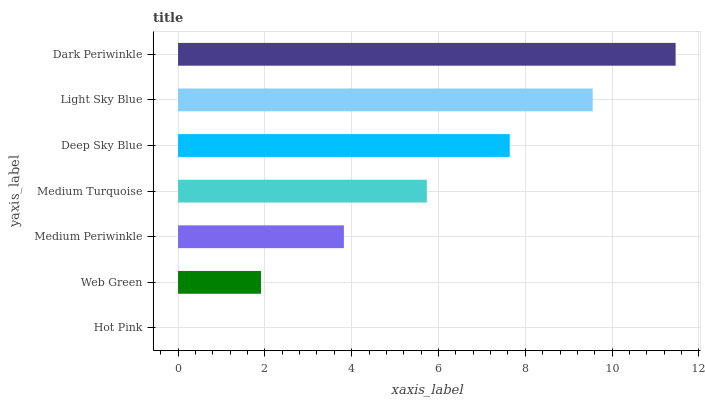Is Hot Pink the minimum?
Answer yes or no. Yes. Is Dark Periwinkle the maximum?
Answer yes or no. Yes. Is Web Green the minimum?
Answer yes or no. No. Is Web Green the maximum?
Answer yes or no. No. Is Web Green greater than Hot Pink?
Answer yes or no. Yes. Is Hot Pink less than Web Green?
Answer yes or no. Yes. Is Hot Pink greater than Web Green?
Answer yes or no. No. Is Web Green less than Hot Pink?
Answer yes or no. No. Is Medium Turquoise the high median?
Answer yes or no. Yes. Is Medium Turquoise the low median?
Answer yes or no. Yes. Is Dark Periwinkle the high median?
Answer yes or no. No. Is Hot Pink the low median?
Answer yes or no. No. 